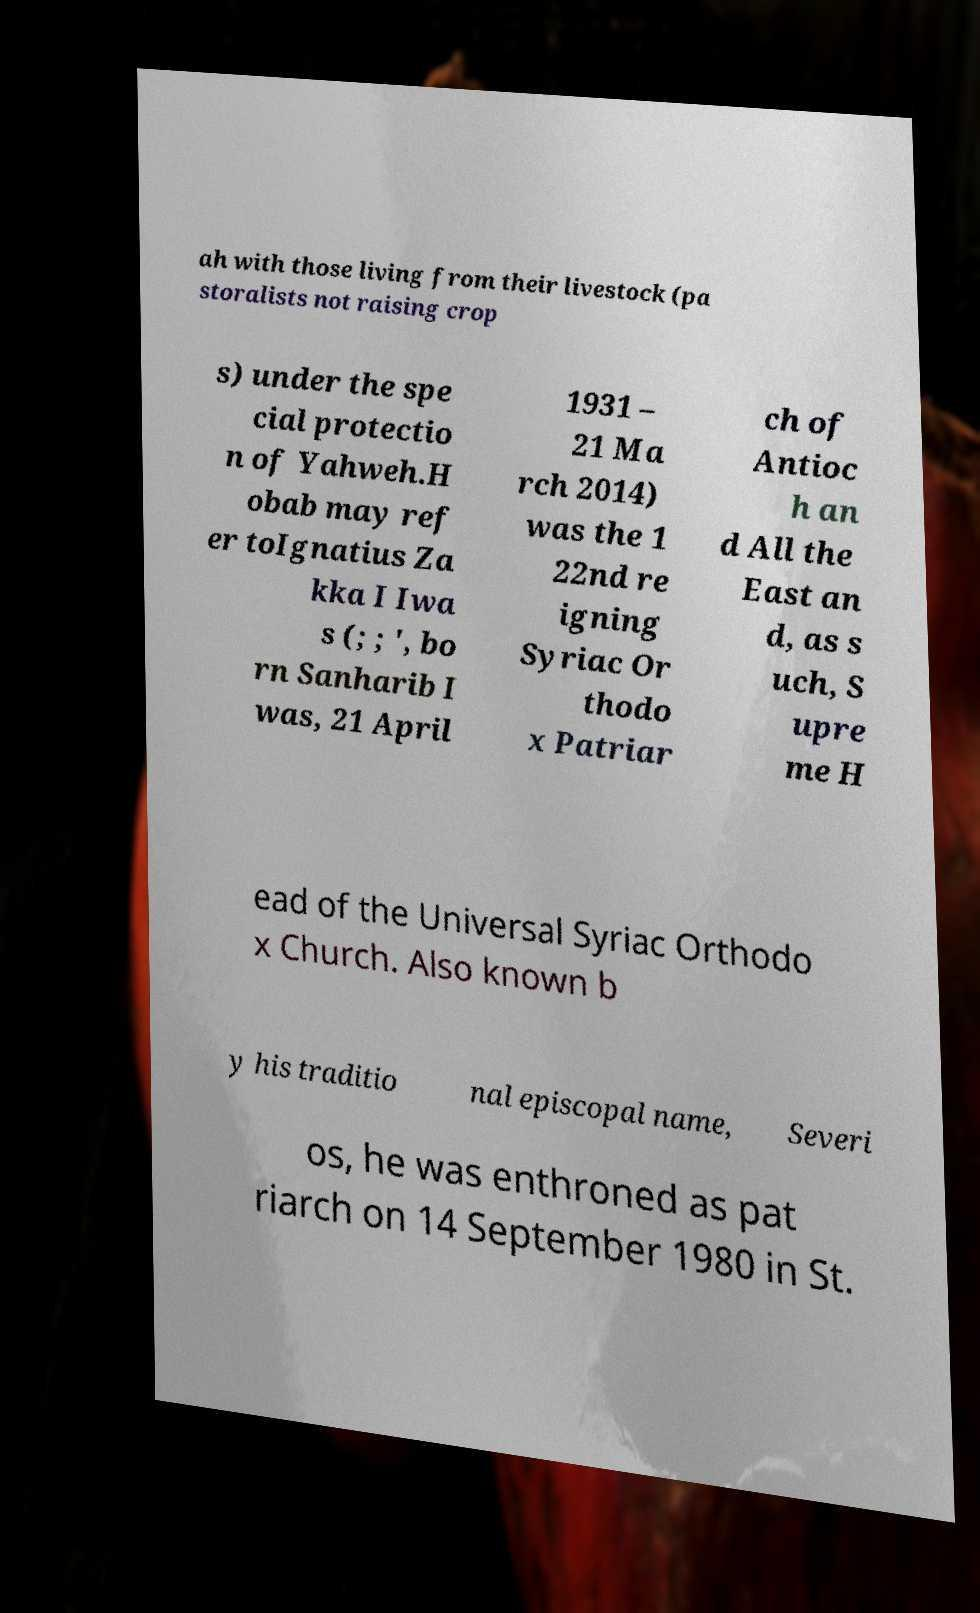Could you assist in decoding the text presented in this image and type it out clearly? ah with those living from their livestock (pa storalists not raising crop s) under the spe cial protectio n of Yahweh.H obab may ref er toIgnatius Za kka I Iwa s (; ; ', bo rn Sanharib I was, 21 April 1931 – 21 Ma rch 2014) was the 1 22nd re igning Syriac Or thodo x Patriar ch of Antioc h an d All the East an d, as s uch, S upre me H ead of the Universal Syriac Orthodo x Church. Also known b y his traditio nal episcopal name, Severi os, he was enthroned as pat riarch on 14 September 1980 in St. 